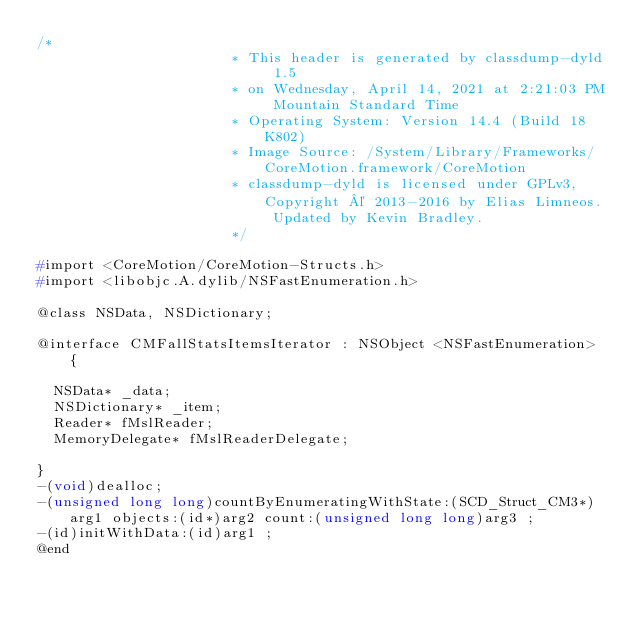Convert code to text. <code><loc_0><loc_0><loc_500><loc_500><_C_>/*
                       * This header is generated by classdump-dyld 1.5
                       * on Wednesday, April 14, 2021 at 2:21:03 PM Mountain Standard Time
                       * Operating System: Version 14.4 (Build 18K802)
                       * Image Source: /System/Library/Frameworks/CoreMotion.framework/CoreMotion
                       * classdump-dyld is licensed under GPLv3, Copyright © 2013-2016 by Elias Limneos. Updated by Kevin Bradley.
                       */

#import <CoreMotion/CoreMotion-Structs.h>
#import <libobjc.A.dylib/NSFastEnumeration.h>

@class NSData, NSDictionary;

@interface CMFallStatsItemsIterator : NSObject <NSFastEnumeration> {

	NSData* _data;
	NSDictionary* _item;
	Reader* fMslReader;
	MemoryDelegate* fMslReaderDelegate;

}
-(void)dealloc;
-(unsigned long long)countByEnumeratingWithState:(SCD_Struct_CM3*)arg1 objects:(id*)arg2 count:(unsigned long long)arg3 ;
-(id)initWithData:(id)arg1 ;
@end

</code> 